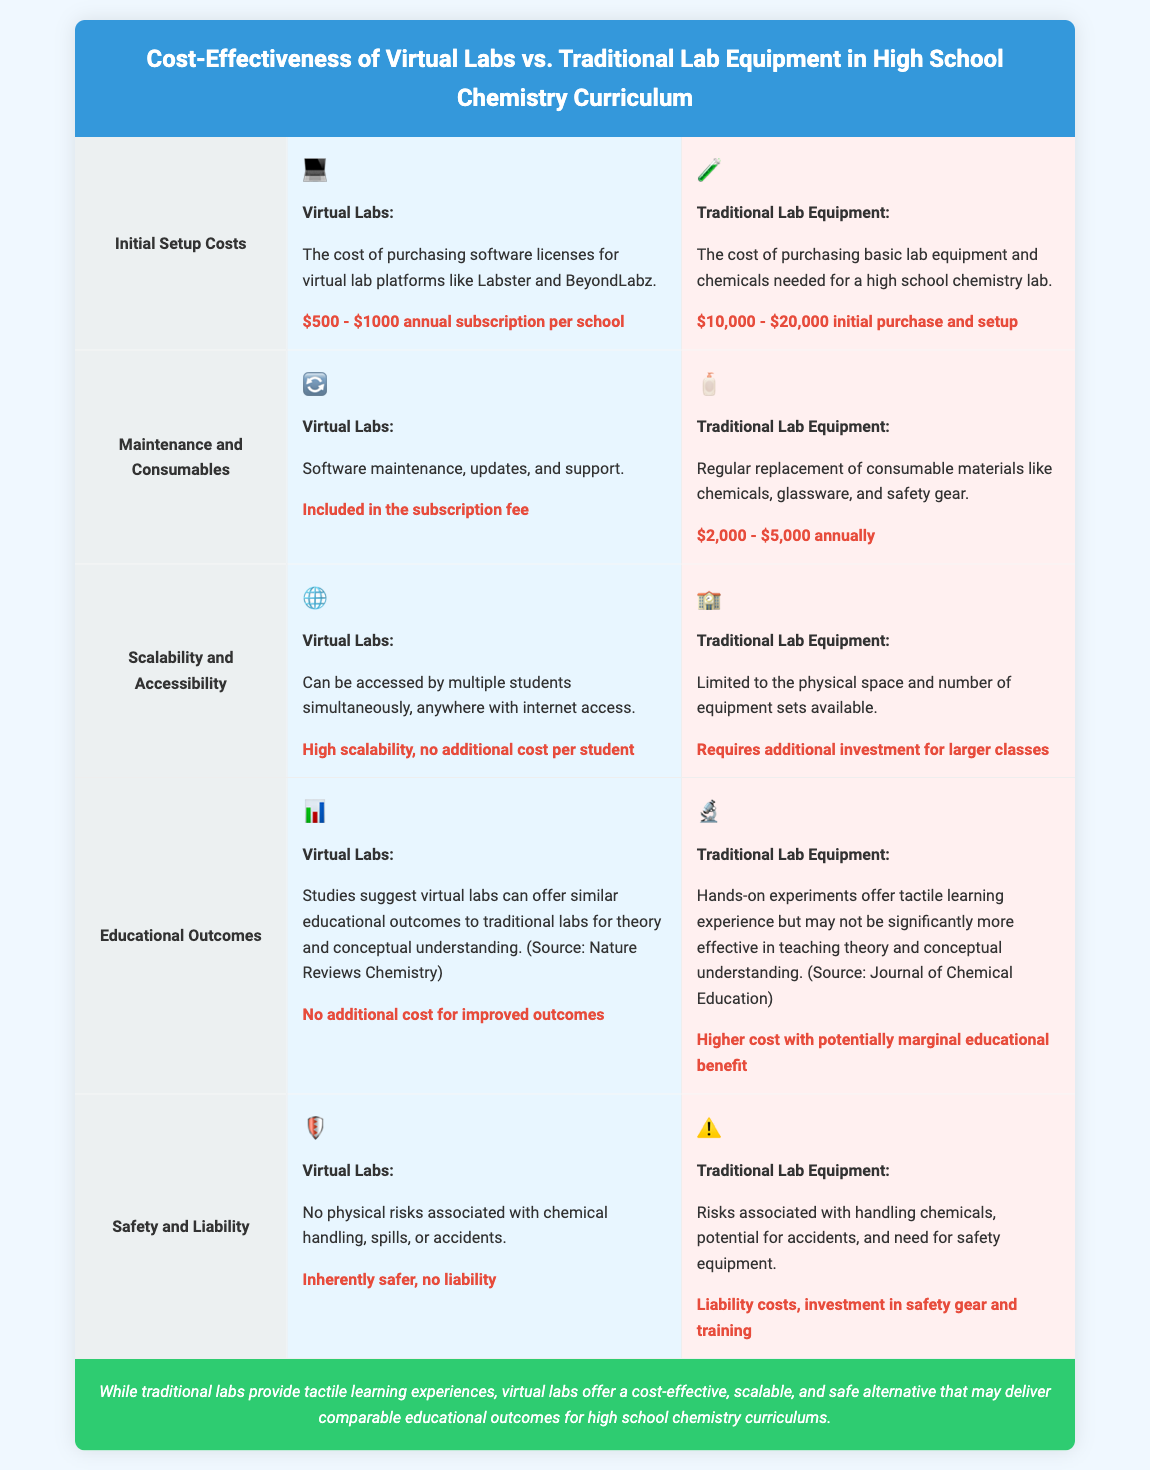What is the cost of virtual lab subscriptions? The document states that the cost of purchasing software licenses for virtual lab platforms like Labster and BeyondLabz is $500 - $1000 annual subscription per school.
Answer: $500 - $1000 annual subscription per school What are the maintenance costs for virtual labs? According to the document, software maintenance, updates, and support for virtual labs are included in the subscription fee.
Answer: Included in the subscription fee What is the initial setup cost for traditional lab equipment? The initial purchase and setup costs for traditional lab equipment and chemicals range from $10,000 to $20,000.
Answer: $10,000 - $20,000 initial purchase and setup What is one advantage of virtual labs regarding scalability? The document mentions that virtual labs can be accessed by multiple students simultaneously, indicating high scalability with no additional cost per student.
Answer: High scalability, no additional cost per student Which type of labs offers tactile learning experiences? The document states that traditional lab equipment provides tactile learning experiences.
Answer: Traditional lab equipment What do studies suggest about educational outcomes of virtual labs? The document notes studies suggesting virtual labs can offer similar educational outcomes to traditional labs for theory and conceptual understanding.
Answer: Similar educational outcomes Which has lower liabilities, virtual labs or traditional labs? The document clearly states that virtual labs are inherently safer with no liability associated with chemical handling.
Answer: Virtual labs What are the total annual maintenance costs for traditional lab equipment? The document states that traditional lab equipment incurs annual replacement costs for consumables, ranging from $2,000 to $5,000 annually.
Answer: $2,000 - $5,000 annually What do traditional lab experiments require in terms of investment? According to the document, traditional labs require investment in safety gear and training due to risks associated with handling chemicals.
Answer: Investment in safety gear and training 